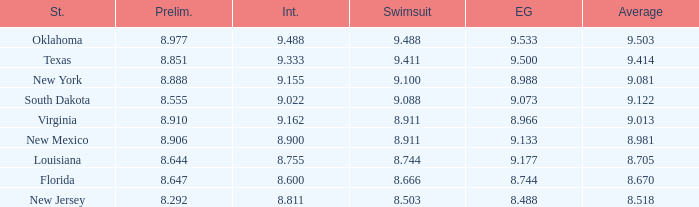 what's the preliminaries where state is south dakota 8.555. 